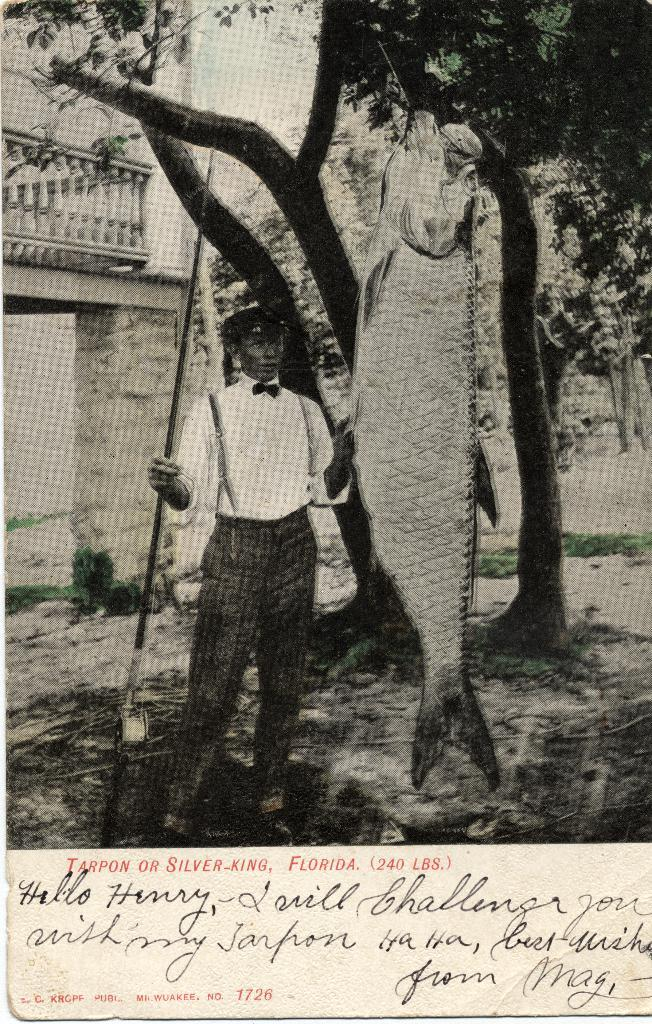What is the color scheme of the image? The image is in black and white. What can be seen in the foreground of the image? There is a man standing in the image. What is the man holding in his hand? The man is holding a fish in his hand. What can be seen in the background of the image? There are trees and a building visible in the background of the image. What is written on the building? There is writing on the building. Where is the robin perched in the image? There is no robin present in the image. What type of bottle is being used to catch the fish in the image? There is no bottle visible in the image; the man is holding the fish in his hand. 